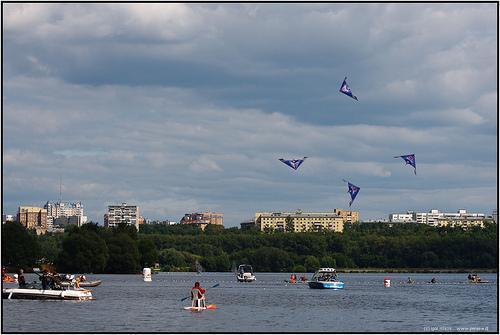How many kites are in the sky?
Give a very brief answer. 4. How many people are walking on water?
Give a very brief answer. 0. 